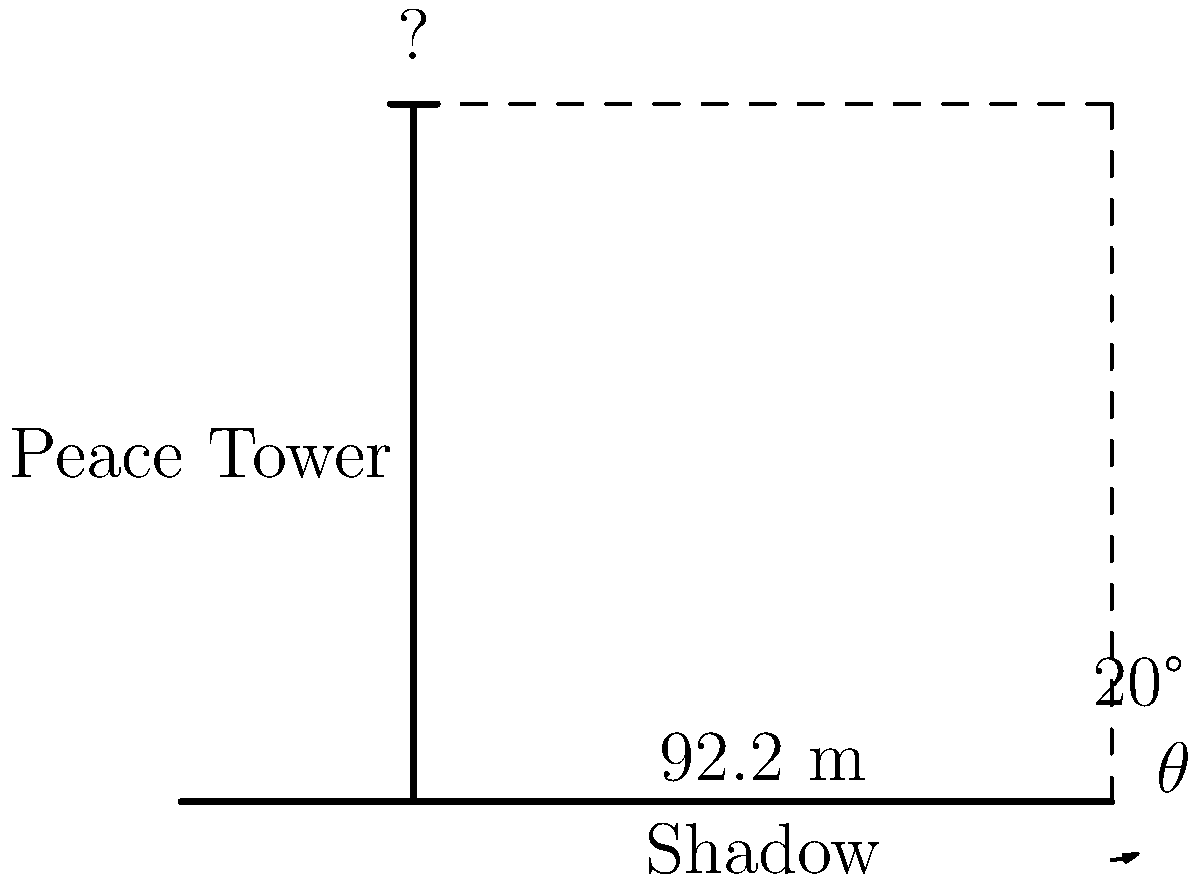As a constitutional law scholar with an appreciation for Canadian history, you're visiting Parliament Hill in Ottawa. While admiring the iconic Peace Tower, you notice its shadow stretching across the grounds. Given that the angle of elevation of the sun is 20°, and the length of the Peace Tower's shadow is 92.2 meters, calculate the height of the Peace Tower. How does this height compare to the symbolic significance of the tower in Canadian parliamentary history? Let's approach this step-by-step using trigonometry:

1) In a right triangle formed by the Peace Tower, its shadow, and the sun's rays, we have:
   - The adjacent side (shadow length) = 92.2 meters
   - The angle of elevation = 20°
   - We need to find the opposite side (tower height)

2) The tangent function relates the opposite and adjacent sides:
   $\tan \theta = \frac{\text{opposite}}{\text{adjacent}}$

3) Substituting our known values:
   $\tan 20° = \frac{\text{tower height}}{92.2}$

4) Solving for the tower height:
   $\text{tower height} = 92.2 \times \tan 20°$

5) Calculate:
   $\text{tower height} = 92.2 \times 0.3640$
   $\text{tower height} = 33.56$ meters

6) Rounding to the nearest tenth:
   $\text{tower height} \approx 33.6$ meters

Historically, the Peace Tower stands at 92.2 meters tall, which is significantly higher than our calculation. This discrepancy might be due to the time of day affecting the shadow length or other factors not accounted for in our simplified model.

The actual height of 92.2 meters was chosen deliberately, with each foot representing 1,000 Canadians at the time of its construction in the 1920s. This height symbolizes the tower's role as a monument to all Canadians and their sacrifices, particularly those who died in World War I.
Answer: 33.6 meters 